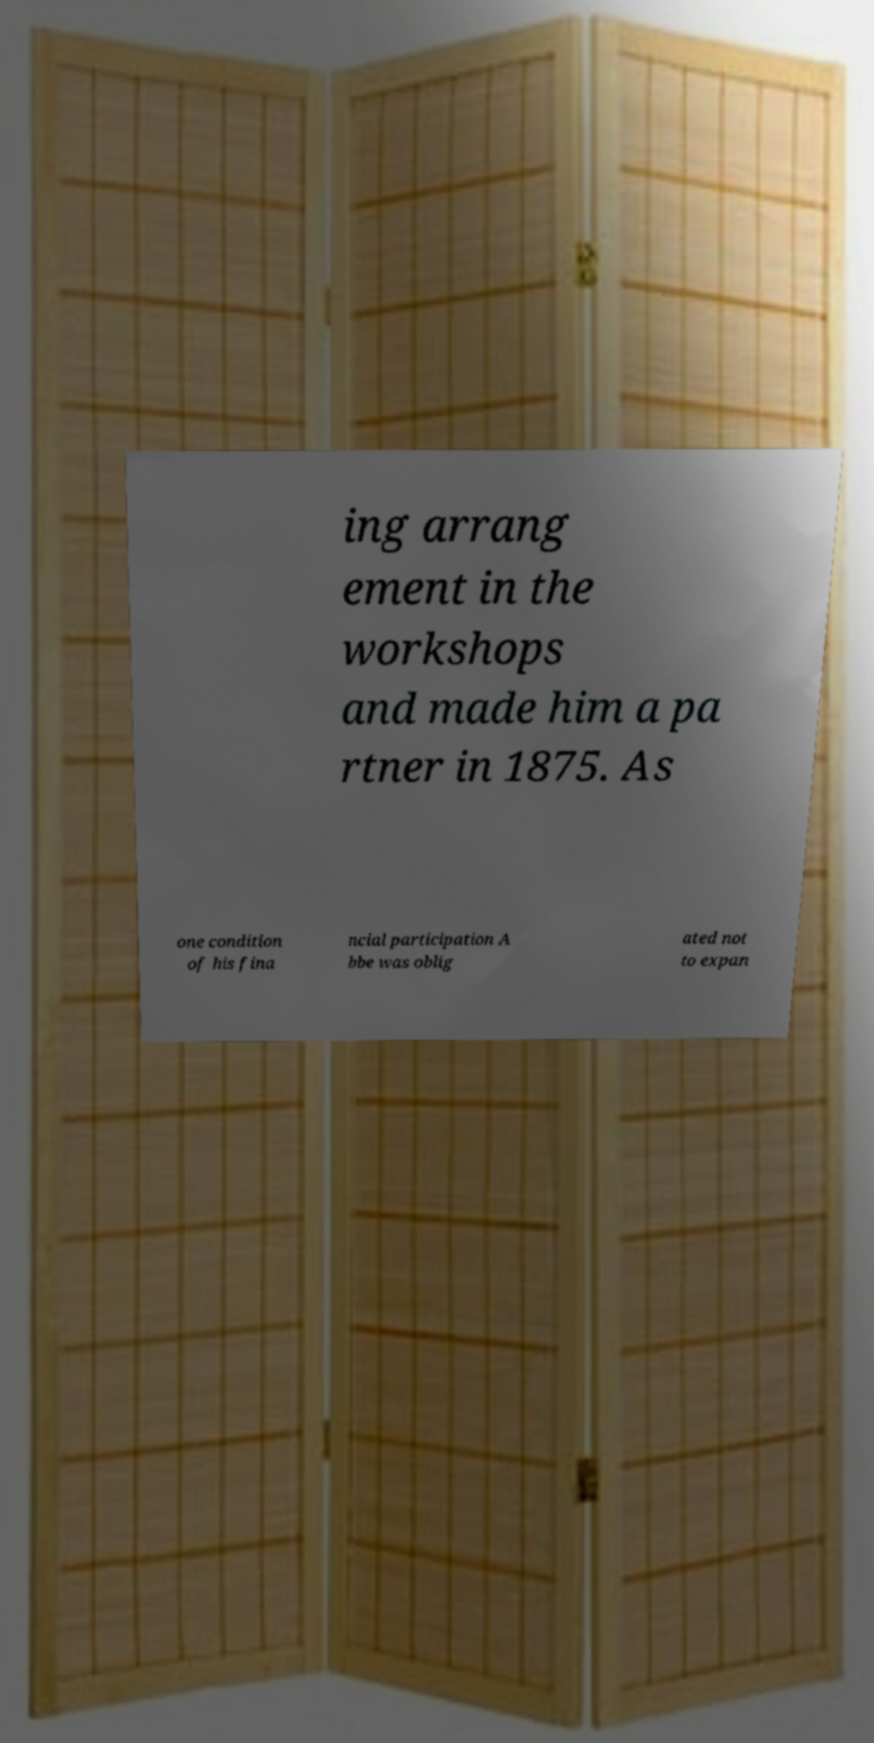Please identify and transcribe the text found in this image. ing arrang ement in the workshops and made him a pa rtner in 1875. As one condition of his fina ncial participation A bbe was oblig ated not to expan 